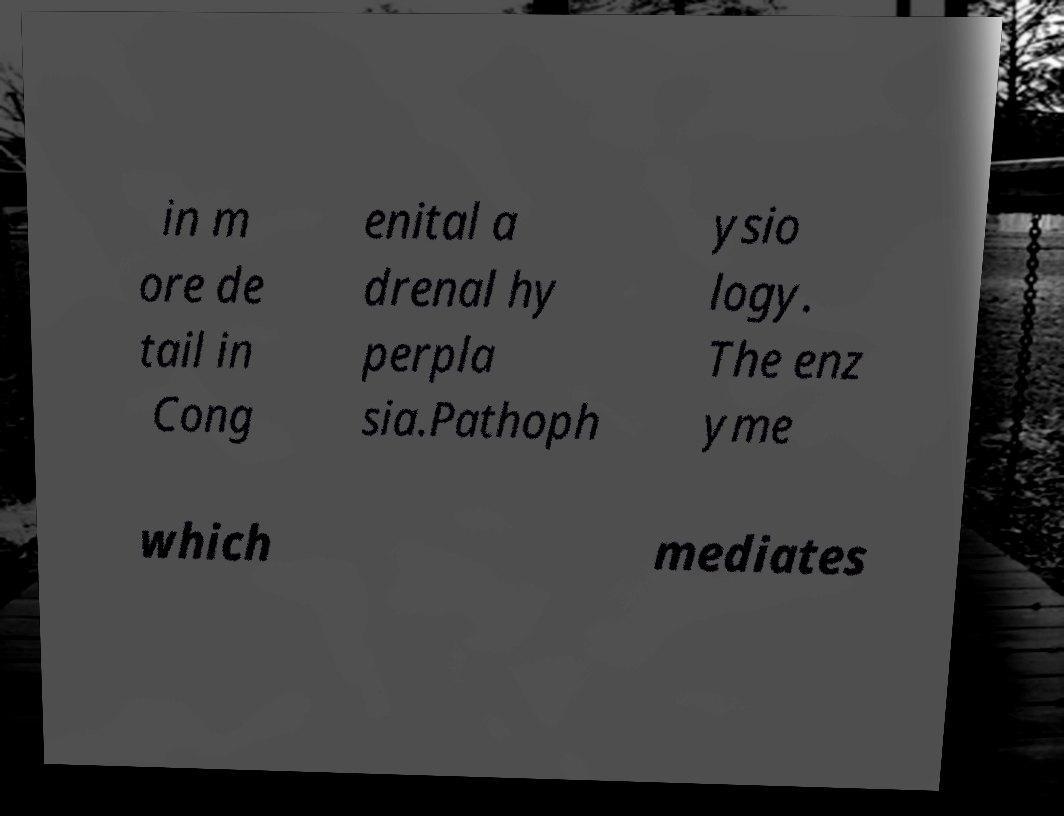I need the written content from this picture converted into text. Can you do that? in m ore de tail in Cong enital a drenal hy perpla sia.Pathoph ysio logy. The enz yme which mediates 